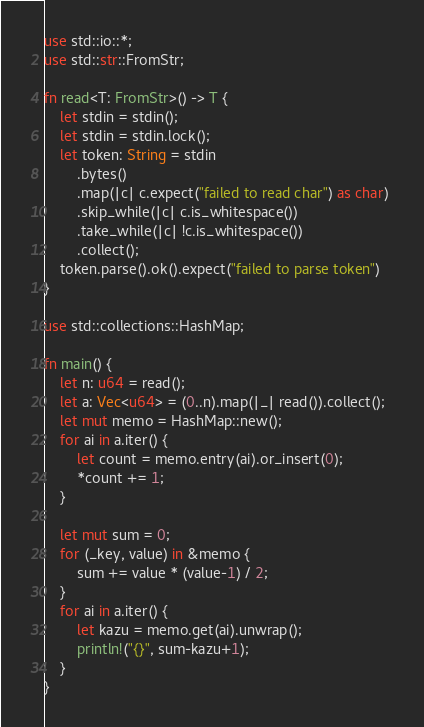<code> <loc_0><loc_0><loc_500><loc_500><_Rust_>use std::io::*;
use std::str::FromStr;

fn read<T: FromStr>() -> T {
    let stdin = stdin();
    let stdin = stdin.lock();
    let token: String = stdin
        .bytes()
        .map(|c| c.expect("failed to read char") as char) 
        .skip_while(|c| c.is_whitespace())
        .take_while(|c| !c.is_whitespace())
        .collect();
    token.parse().ok().expect("failed to parse token")
}

use std::collections::HashMap;

fn main() {
    let n: u64 = read();
    let a: Vec<u64> = (0..n).map(|_| read()).collect();
    let mut memo = HashMap::new();
    for ai in a.iter() {
        let count = memo.entry(ai).or_insert(0);
        *count += 1;        
    }

    let mut sum = 0;
    for (_key, value) in &memo {
        sum += value * (value-1) / 2;
    }
    for ai in a.iter() {
        let kazu = memo.get(ai).unwrap();
        println!("{}", sum-kazu+1);
    }
}
</code> 